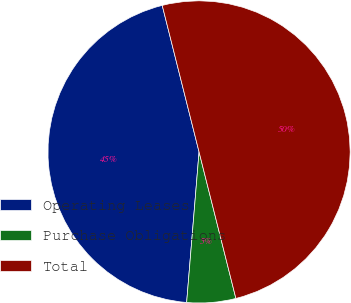<chart> <loc_0><loc_0><loc_500><loc_500><pie_chart><fcel>Operating Leases<fcel>Purchase Obligations<fcel>Total<nl><fcel>44.77%<fcel>5.23%<fcel>50.0%<nl></chart> 